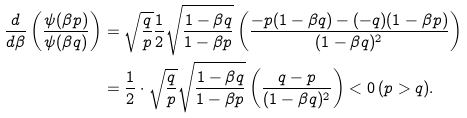Convert formula to latex. <formula><loc_0><loc_0><loc_500><loc_500>\frac { d } { d \beta } \left ( \frac { \psi ( \beta p ) } { \psi ( \beta q ) } \right ) & = \sqrt { \frac { q } { p } } \frac { 1 } { 2 } \sqrt { \frac { 1 - \beta q } { 1 - \beta p } } \left ( \frac { - p ( 1 - \beta q ) - ( - q ) ( 1 - \beta p ) } { ( 1 - \beta q ) ^ { 2 } } \right ) \\ & = \frac { 1 } { 2 } \cdot \sqrt { \frac { q } { p } } \sqrt { \frac { 1 - \beta q } { 1 - \beta p } } \left ( \frac { q - p } { ( 1 - \beta q ) ^ { 2 } } \right ) < 0 \, ( p > q ) .</formula> 